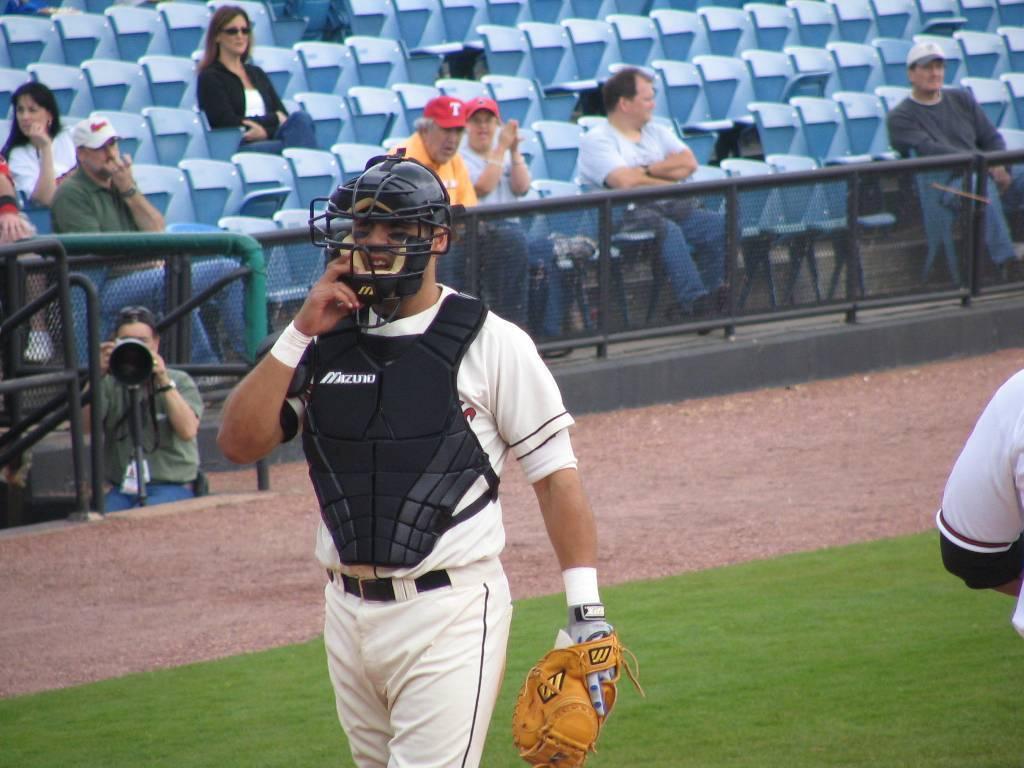What letter is on the old man's red hat?
Your answer should be very brief. T. 